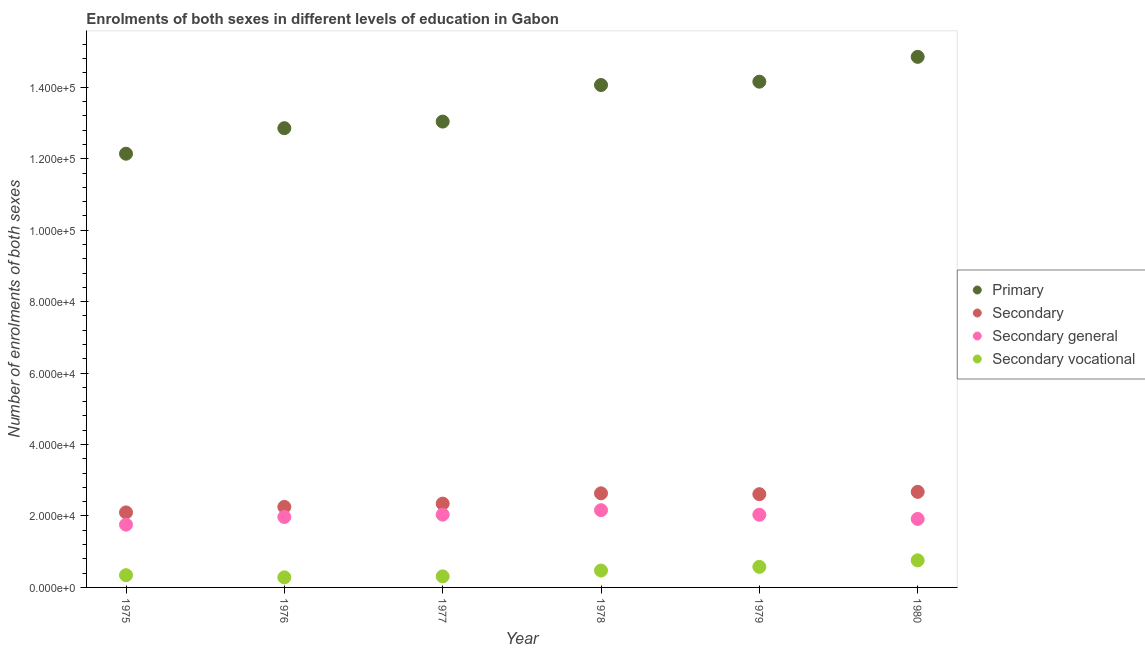What is the number of enrolments in secondary general education in 1977?
Offer a terse response. 2.04e+04. Across all years, what is the maximum number of enrolments in secondary vocational education?
Your response must be concise. 7577. Across all years, what is the minimum number of enrolments in secondary general education?
Your answer should be very brief. 1.76e+04. In which year was the number of enrolments in secondary general education maximum?
Your answer should be very brief. 1978. In which year was the number of enrolments in secondary education minimum?
Offer a very short reply. 1975. What is the total number of enrolments in primary education in the graph?
Make the answer very short. 8.11e+05. What is the difference between the number of enrolments in primary education in 1975 and that in 1978?
Offer a very short reply. -1.92e+04. What is the difference between the number of enrolments in secondary education in 1975 and the number of enrolments in secondary general education in 1979?
Offer a terse response. 655. What is the average number of enrolments in secondary general education per year?
Give a very brief answer. 1.98e+04. In the year 1980, what is the difference between the number of enrolments in secondary vocational education and number of enrolments in secondary general education?
Make the answer very short. -1.16e+04. In how many years, is the number of enrolments in secondary general education greater than 76000?
Offer a very short reply. 0. What is the ratio of the number of enrolments in primary education in 1975 to that in 1978?
Make the answer very short. 0.86. Is the difference between the number of enrolments in secondary education in 1976 and 1978 greater than the difference between the number of enrolments in secondary general education in 1976 and 1978?
Provide a short and direct response. No. What is the difference between the highest and the second highest number of enrolments in secondary general education?
Provide a short and direct response. 1247. What is the difference between the highest and the lowest number of enrolments in secondary vocational education?
Ensure brevity in your answer.  4756. In how many years, is the number of enrolments in secondary vocational education greater than the average number of enrolments in secondary vocational education taken over all years?
Keep it short and to the point. 3. How many dotlines are there?
Your answer should be very brief. 4. How many years are there in the graph?
Your answer should be compact. 6. Are the values on the major ticks of Y-axis written in scientific E-notation?
Keep it short and to the point. Yes. What is the title of the graph?
Your response must be concise. Enrolments of both sexes in different levels of education in Gabon. What is the label or title of the Y-axis?
Give a very brief answer. Number of enrolments of both sexes. What is the Number of enrolments of both sexes in Primary in 1975?
Offer a terse response. 1.21e+05. What is the Number of enrolments of both sexes of Secondary in 1975?
Provide a succinct answer. 2.10e+04. What is the Number of enrolments of both sexes of Secondary general in 1975?
Ensure brevity in your answer.  1.76e+04. What is the Number of enrolments of both sexes in Secondary vocational in 1975?
Keep it short and to the point. 3424. What is the Number of enrolments of both sexes in Primary in 1976?
Offer a terse response. 1.29e+05. What is the Number of enrolments of both sexes in Secondary in 1976?
Keep it short and to the point. 2.25e+04. What is the Number of enrolments of both sexes of Secondary general in 1976?
Keep it short and to the point. 1.97e+04. What is the Number of enrolments of both sexes in Secondary vocational in 1976?
Give a very brief answer. 2821. What is the Number of enrolments of both sexes in Primary in 1977?
Provide a short and direct response. 1.30e+05. What is the Number of enrolments of both sexes of Secondary in 1977?
Provide a succinct answer. 2.35e+04. What is the Number of enrolments of both sexes of Secondary general in 1977?
Your answer should be very brief. 2.04e+04. What is the Number of enrolments of both sexes of Secondary vocational in 1977?
Keep it short and to the point. 3093. What is the Number of enrolments of both sexes of Primary in 1978?
Make the answer very short. 1.41e+05. What is the Number of enrolments of both sexes of Secondary in 1978?
Give a very brief answer. 2.63e+04. What is the Number of enrolments of both sexes in Secondary general in 1978?
Offer a terse response. 2.16e+04. What is the Number of enrolments of both sexes in Secondary vocational in 1978?
Offer a very short reply. 4728. What is the Number of enrolments of both sexes in Primary in 1979?
Give a very brief answer. 1.42e+05. What is the Number of enrolments of both sexes in Secondary in 1979?
Your answer should be compact. 2.61e+04. What is the Number of enrolments of both sexes of Secondary general in 1979?
Your response must be concise. 2.03e+04. What is the Number of enrolments of both sexes of Secondary vocational in 1979?
Provide a succinct answer. 5759. What is the Number of enrolments of both sexes in Primary in 1980?
Provide a succinct answer. 1.49e+05. What is the Number of enrolments of both sexes in Secondary in 1980?
Keep it short and to the point. 2.68e+04. What is the Number of enrolments of both sexes in Secondary general in 1980?
Your response must be concise. 1.92e+04. What is the Number of enrolments of both sexes in Secondary vocational in 1980?
Offer a very short reply. 7577. Across all years, what is the maximum Number of enrolments of both sexes in Primary?
Provide a short and direct response. 1.49e+05. Across all years, what is the maximum Number of enrolments of both sexes in Secondary?
Offer a terse response. 2.68e+04. Across all years, what is the maximum Number of enrolments of both sexes of Secondary general?
Keep it short and to the point. 2.16e+04. Across all years, what is the maximum Number of enrolments of both sexes of Secondary vocational?
Keep it short and to the point. 7577. Across all years, what is the minimum Number of enrolments of both sexes in Primary?
Your answer should be compact. 1.21e+05. Across all years, what is the minimum Number of enrolments of both sexes of Secondary?
Provide a short and direct response. 2.10e+04. Across all years, what is the minimum Number of enrolments of both sexes in Secondary general?
Ensure brevity in your answer.  1.76e+04. Across all years, what is the minimum Number of enrolments of both sexes in Secondary vocational?
Provide a succinct answer. 2821. What is the total Number of enrolments of both sexes in Primary in the graph?
Make the answer very short. 8.11e+05. What is the total Number of enrolments of both sexes in Secondary in the graph?
Provide a succinct answer. 1.46e+05. What is the total Number of enrolments of both sexes in Secondary general in the graph?
Make the answer very short. 1.19e+05. What is the total Number of enrolments of both sexes in Secondary vocational in the graph?
Make the answer very short. 2.74e+04. What is the difference between the Number of enrolments of both sexes of Primary in 1975 and that in 1976?
Give a very brief answer. -7145. What is the difference between the Number of enrolments of both sexes in Secondary in 1975 and that in 1976?
Make the answer very short. -1543. What is the difference between the Number of enrolments of both sexes in Secondary general in 1975 and that in 1976?
Give a very brief answer. -2146. What is the difference between the Number of enrolments of both sexes in Secondary vocational in 1975 and that in 1976?
Give a very brief answer. 603. What is the difference between the Number of enrolments of both sexes of Primary in 1975 and that in 1977?
Your response must be concise. -8991. What is the difference between the Number of enrolments of both sexes in Secondary in 1975 and that in 1977?
Ensure brevity in your answer.  -2461. What is the difference between the Number of enrolments of both sexes in Secondary general in 1975 and that in 1977?
Offer a very short reply. -2792. What is the difference between the Number of enrolments of both sexes in Secondary vocational in 1975 and that in 1977?
Give a very brief answer. 331. What is the difference between the Number of enrolments of both sexes of Primary in 1975 and that in 1978?
Provide a succinct answer. -1.92e+04. What is the difference between the Number of enrolments of both sexes of Secondary in 1975 and that in 1978?
Your answer should be very brief. -5343. What is the difference between the Number of enrolments of both sexes in Secondary general in 1975 and that in 1978?
Provide a short and direct response. -4039. What is the difference between the Number of enrolments of both sexes of Secondary vocational in 1975 and that in 1978?
Give a very brief answer. -1304. What is the difference between the Number of enrolments of both sexes of Primary in 1975 and that in 1979?
Your answer should be compact. -2.02e+04. What is the difference between the Number of enrolments of both sexes of Secondary in 1975 and that in 1979?
Your response must be concise. -5104. What is the difference between the Number of enrolments of both sexes in Secondary general in 1975 and that in 1979?
Ensure brevity in your answer.  -2769. What is the difference between the Number of enrolments of both sexes of Secondary vocational in 1975 and that in 1979?
Keep it short and to the point. -2335. What is the difference between the Number of enrolments of both sexes of Primary in 1975 and that in 1980?
Your answer should be very brief. -2.71e+04. What is the difference between the Number of enrolments of both sexes of Secondary in 1975 and that in 1980?
Ensure brevity in your answer.  -5751. What is the difference between the Number of enrolments of both sexes of Secondary general in 1975 and that in 1980?
Keep it short and to the point. -1598. What is the difference between the Number of enrolments of both sexes of Secondary vocational in 1975 and that in 1980?
Offer a terse response. -4153. What is the difference between the Number of enrolments of both sexes of Primary in 1976 and that in 1977?
Keep it short and to the point. -1846. What is the difference between the Number of enrolments of both sexes of Secondary in 1976 and that in 1977?
Give a very brief answer. -918. What is the difference between the Number of enrolments of both sexes in Secondary general in 1976 and that in 1977?
Provide a succinct answer. -646. What is the difference between the Number of enrolments of both sexes of Secondary vocational in 1976 and that in 1977?
Keep it short and to the point. -272. What is the difference between the Number of enrolments of both sexes of Primary in 1976 and that in 1978?
Provide a succinct answer. -1.21e+04. What is the difference between the Number of enrolments of both sexes of Secondary in 1976 and that in 1978?
Your response must be concise. -3800. What is the difference between the Number of enrolments of both sexes in Secondary general in 1976 and that in 1978?
Offer a very short reply. -1893. What is the difference between the Number of enrolments of both sexes of Secondary vocational in 1976 and that in 1978?
Your answer should be very brief. -1907. What is the difference between the Number of enrolments of both sexes in Primary in 1976 and that in 1979?
Keep it short and to the point. -1.30e+04. What is the difference between the Number of enrolments of both sexes of Secondary in 1976 and that in 1979?
Give a very brief answer. -3561. What is the difference between the Number of enrolments of both sexes of Secondary general in 1976 and that in 1979?
Your response must be concise. -623. What is the difference between the Number of enrolments of both sexes of Secondary vocational in 1976 and that in 1979?
Provide a short and direct response. -2938. What is the difference between the Number of enrolments of both sexes in Primary in 1976 and that in 1980?
Your response must be concise. -2.00e+04. What is the difference between the Number of enrolments of both sexes of Secondary in 1976 and that in 1980?
Offer a very short reply. -4208. What is the difference between the Number of enrolments of both sexes in Secondary general in 1976 and that in 1980?
Your answer should be very brief. 548. What is the difference between the Number of enrolments of both sexes in Secondary vocational in 1976 and that in 1980?
Your answer should be very brief. -4756. What is the difference between the Number of enrolments of both sexes of Primary in 1977 and that in 1978?
Provide a succinct answer. -1.02e+04. What is the difference between the Number of enrolments of both sexes in Secondary in 1977 and that in 1978?
Keep it short and to the point. -2882. What is the difference between the Number of enrolments of both sexes of Secondary general in 1977 and that in 1978?
Provide a succinct answer. -1247. What is the difference between the Number of enrolments of both sexes in Secondary vocational in 1977 and that in 1978?
Keep it short and to the point. -1635. What is the difference between the Number of enrolments of both sexes of Primary in 1977 and that in 1979?
Your response must be concise. -1.12e+04. What is the difference between the Number of enrolments of both sexes of Secondary in 1977 and that in 1979?
Keep it short and to the point. -2643. What is the difference between the Number of enrolments of both sexes in Secondary general in 1977 and that in 1979?
Give a very brief answer. 23. What is the difference between the Number of enrolments of both sexes of Secondary vocational in 1977 and that in 1979?
Offer a terse response. -2666. What is the difference between the Number of enrolments of both sexes in Primary in 1977 and that in 1980?
Ensure brevity in your answer.  -1.81e+04. What is the difference between the Number of enrolments of both sexes in Secondary in 1977 and that in 1980?
Keep it short and to the point. -3290. What is the difference between the Number of enrolments of both sexes of Secondary general in 1977 and that in 1980?
Keep it short and to the point. 1194. What is the difference between the Number of enrolments of both sexes in Secondary vocational in 1977 and that in 1980?
Offer a terse response. -4484. What is the difference between the Number of enrolments of both sexes of Primary in 1978 and that in 1979?
Provide a short and direct response. -937. What is the difference between the Number of enrolments of both sexes of Secondary in 1978 and that in 1979?
Provide a short and direct response. 239. What is the difference between the Number of enrolments of both sexes in Secondary general in 1978 and that in 1979?
Provide a short and direct response. 1270. What is the difference between the Number of enrolments of both sexes of Secondary vocational in 1978 and that in 1979?
Keep it short and to the point. -1031. What is the difference between the Number of enrolments of both sexes in Primary in 1978 and that in 1980?
Provide a short and direct response. -7888. What is the difference between the Number of enrolments of both sexes in Secondary in 1978 and that in 1980?
Offer a very short reply. -408. What is the difference between the Number of enrolments of both sexes in Secondary general in 1978 and that in 1980?
Provide a short and direct response. 2441. What is the difference between the Number of enrolments of both sexes in Secondary vocational in 1978 and that in 1980?
Give a very brief answer. -2849. What is the difference between the Number of enrolments of both sexes of Primary in 1979 and that in 1980?
Make the answer very short. -6951. What is the difference between the Number of enrolments of both sexes in Secondary in 1979 and that in 1980?
Your answer should be very brief. -647. What is the difference between the Number of enrolments of both sexes in Secondary general in 1979 and that in 1980?
Keep it short and to the point. 1171. What is the difference between the Number of enrolments of both sexes of Secondary vocational in 1979 and that in 1980?
Offer a very short reply. -1818. What is the difference between the Number of enrolments of both sexes in Primary in 1975 and the Number of enrolments of both sexes in Secondary in 1976?
Offer a very short reply. 9.89e+04. What is the difference between the Number of enrolments of both sexes in Primary in 1975 and the Number of enrolments of both sexes in Secondary general in 1976?
Offer a very short reply. 1.02e+05. What is the difference between the Number of enrolments of both sexes in Primary in 1975 and the Number of enrolments of both sexes in Secondary vocational in 1976?
Provide a short and direct response. 1.19e+05. What is the difference between the Number of enrolments of both sexes in Secondary in 1975 and the Number of enrolments of both sexes in Secondary general in 1976?
Your answer should be very brief. 1278. What is the difference between the Number of enrolments of both sexes in Secondary in 1975 and the Number of enrolments of both sexes in Secondary vocational in 1976?
Keep it short and to the point. 1.82e+04. What is the difference between the Number of enrolments of both sexes in Secondary general in 1975 and the Number of enrolments of both sexes in Secondary vocational in 1976?
Give a very brief answer. 1.48e+04. What is the difference between the Number of enrolments of both sexes in Primary in 1975 and the Number of enrolments of both sexes in Secondary in 1977?
Provide a short and direct response. 9.79e+04. What is the difference between the Number of enrolments of both sexes in Primary in 1975 and the Number of enrolments of both sexes in Secondary general in 1977?
Offer a very short reply. 1.01e+05. What is the difference between the Number of enrolments of both sexes of Primary in 1975 and the Number of enrolments of both sexes of Secondary vocational in 1977?
Your answer should be compact. 1.18e+05. What is the difference between the Number of enrolments of both sexes in Secondary in 1975 and the Number of enrolments of both sexes in Secondary general in 1977?
Make the answer very short. 632. What is the difference between the Number of enrolments of both sexes of Secondary in 1975 and the Number of enrolments of both sexes of Secondary vocational in 1977?
Your response must be concise. 1.79e+04. What is the difference between the Number of enrolments of both sexes in Secondary general in 1975 and the Number of enrolments of both sexes in Secondary vocational in 1977?
Your answer should be very brief. 1.45e+04. What is the difference between the Number of enrolments of both sexes of Primary in 1975 and the Number of enrolments of both sexes of Secondary in 1978?
Offer a terse response. 9.51e+04. What is the difference between the Number of enrolments of both sexes in Primary in 1975 and the Number of enrolments of both sexes in Secondary general in 1978?
Keep it short and to the point. 9.98e+04. What is the difference between the Number of enrolments of both sexes of Primary in 1975 and the Number of enrolments of both sexes of Secondary vocational in 1978?
Your answer should be compact. 1.17e+05. What is the difference between the Number of enrolments of both sexes in Secondary in 1975 and the Number of enrolments of both sexes in Secondary general in 1978?
Provide a succinct answer. -615. What is the difference between the Number of enrolments of both sexes in Secondary in 1975 and the Number of enrolments of both sexes in Secondary vocational in 1978?
Keep it short and to the point. 1.63e+04. What is the difference between the Number of enrolments of both sexes of Secondary general in 1975 and the Number of enrolments of both sexes of Secondary vocational in 1978?
Provide a succinct answer. 1.28e+04. What is the difference between the Number of enrolments of both sexes in Primary in 1975 and the Number of enrolments of both sexes in Secondary in 1979?
Your answer should be very brief. 9.53e+04. What is the difference between the Number of enrolments of both sexes of Primary in 1975 and the Number of enrolments of both sexes of Secondary general in 1979?
Your answer should be compact. 1.01e+05. What is the difference between the Number of enrolments of both sexes in Primary in 1975 and the Number of enrolments of both sexes in Secondary vocational in 1979?
Keep it short and to the point. 1.16e+05. What is the difference between the Number of enrolments of both sexes of Secondary in 1975 and the Number of enrolments of both sexes of Secondary general in 1979?
Your response must be concise. 655. What is the difference between the Number of enrolments of both sexes of Secondary in 1975 and the Number of enrolments of both sexes of Secondary vocational in 1979?
Provide a succinct answer. 1.52e+04. What is the difference between the Number of enrolments of both sexes of Secondary general in 1975 and the Number of enrolments of both sexes of Secondary vocational in 1979?
Your answer should be compact. 1.18e+04. What is the difference between the Number of enrolments of both sexes of Primary in 1975 and the Number of enrolments of both sexes of Secondary in 1980?
Provide a short and direct response. 9.47e+04. What is the difference between the Number of enrolments of both sexes of Primary in 1975 and the Number of enrolments of both sexes of Secondary general in 1980?
Keep it short and to the point. 1.02e+05. What is the difference between the Number of enrolments of both sexes of Primary in 1975 and the Number of enrolments of both sexes of Secondary vocational in 1980?
Provide a short and direct response. 1.14e+05. What is the difference between the Number of enrolments of both sexes of Secondary in 1975 and the Number of enrolments of both sexes of Secondary general in 1980?
Provide a short and direct response. 1826. What is the difference between the Number of enrolments of both sexes of Secondary in 1975 and the Number of enrolments of both sexes of Secondary vocational in 1980?
Provide a short and direct response. 1.34e+04. What is the difference between the Number of enrolments of both sexes in Secondary general in 1975 and the Number of enrolments of both sexes in Secondary vocational in 1980?
Make the answer very short. 9998. What is the difference between the Number of enrolments of both sexes in Primary in 1976 and the Number of enrolments of both sexes in Secondary in 1977?
Make the answer very short. 1.05e+05. What is the difference between the Number of enrolments of both sexes of Primary in 1976 and the Number of enrolments of both sexes of Secondary general in 1977?
Ensure brevity in your answer.  1.08e+05. What is the difference between the Number of enrolments of both sexes in Primary in 1976 and the Number of enrolments of both sexes in Secondary vocational in 1977?
Provide a succinct answer. 1.25e+05. What is the difference between the Number of enrolments of both sexes of Secondary in 1976 and the Number of enrolments of both sexes of Secondary general in 1977?
Give a very brief answer. 2175. What is the difference between the Number of enrolments of both sexes in Secondary in 1976 and the Number of enrolments of both sexes in Secondary vocational in 1977?
Provide a succinct answer. 1.94e+04. What is the difference between the Number of enrolments of both sexes in Secondary general in 1976 and the Number of enrolments of both sexes in Secondary vocational in 1977?
Give a very brief answer. 1.66e+04. What is the difference between the Number of enrolments of both sexes in Primary in 1976 and the Number of enrolments of both sexes in Secondary in 1978?
Your answer should be compact. 1.02e+05. What is the difference between the Number of enrolments of both sexes in Primary in 1976 and the Number of enrolments of both sexes in Secondary general in 1978?
Provide a succinct answer. 1.07e+05. What is the difference between the Number of enrolments of both sexes in Primary in 1976 and the Number of enrolments of both sexes in Secondary vocational in 1978?
Offer a terse response. 1.24e+05. What is the difference between the Number of enrolments of both sexes in Secondary in 1976 and the Number of enrolments of both sexes in Secondary general in 1978?
Provide a short and direct response. 928. What is the difference between the Number of enrolments of both sexes of Secondary in 1976 and the Number of enrolments of both sexes of Secondary vocational in 1978?
Provide a succinct answer. 1.78e+04. What is the difference between the Number of enrolments of both sexes in Secondary general in 1976 and the Number of enrolments of both sexes in Secondary vocational in 1978?
Your response must be concise. 1.50e+04. What is the difference between the Number of enrolments of both sexes of Primary in 1976 and the Number of enrolments of both sexes of Secondary in 1979?
Your answer should be compact. 1.02e+05. What is the difference between the Number of enrolments of both sexes in Primary in 1976 and the Number of enrolments of both sexes in Secondary general in 1979?
Give a very brief answer. 1.08e+05. What is the difference between the Number of enrolments of both sexes in Primary in 1976 and the Number of enrolments of both sexes in Secondary vocational in 1979?
Ensure brevity in your answer.  1.23e+05. What is the difference between the Number of enrolments of both sexes in Secondary in 1976 and the Number of enrolments of both sexes in Secondary general in 1979?
Give a very brief answer. 2198. What is the difference between the Number of enrolments of both sexes in Secondary in 1976 and the Number of enrolments of both sexes in Secondary vocational in 1979?
Give a very brief answer. 1.68e+04. What is the difference between the Number of enrolments of both sexes of Secondary general in 1976 and the Number of enrolments of both sexes of Secondary vocational in 1979?
Your answer should be very brief. 1.40e+04. What is the difference between the Number of enrolments of both sexes of Primary in 1976 and the Number of enrolments of both sexes of Secondary in 1980?
Offer a terse response. 1.02e+05. What is the difference between the Number of enrolments of both sexes of Primary in 1976 and the Number of enrolments of both sexes of Secondary general in 1980?
Keep it short and to the point. 1.09e+05. What is the difference between the Number of enrolments of both sexes in Primary in 1976 and the Number of enrolments of both sexes in Secondary vocational in 1980?
Provide a succinct answer. 1.21e+05. What is the difference between the Number of enrolments of both sexes in Secondary in 1976 and the Number of enrolments of both sexes in Secondary general in 1980?
Keep it short and to the point. 3369. What is the difference between the Number of enrolments of both sexes of Secondary in 1976 and the Number of enrolments of both sexes of Secondary vocational in 1980?
Make the answer very short. 1.50e+04. What is the difference between the Number of enrolments of both sexes in Secondary general in 1976 and the Number of enrolments of both sexes in Secondary vocational in 1980?
Give a very brief answer. 1.21e+04. What is the difference between the Number of enrolments of both sexes of Primary in 1977 and the Number of enrolments of both sexes of Secondary in 1978?
Give a very brief answer. 1.04e+05. What is the difference between the Number of enrolments of both sexes of Primary in 1977 and the Number of enrolments of both sexes of Secondary general in 1978?
Keep it short and to the point. 1.09e+05. What is the difference between the Number of enrolments of both sexes of Primary in 1977 and the Number of enrolments of both sexes of Secondary vocational in 1978?
Give a very brief answer. 1.26e+05. What is the difference between the Number of enrolments of both sexes in Secondary in 1977 and the Number of enrolments of both sexes in Secondary general in 1978?
Offer a terse response. 1846. What is the difference between the Number of enrolments of both sexes of Secondary in 1977 and the Number of enrolments of both sexes of Secondary vocational in 1978?
Give a very brief answer. 1.87e+04. What is the difference between the Number of enrolments of both sexes in Secondary general in 1977 and the Number of enrolments of both sexes in Secondary vocational in 1978?
Provide a succinct answer. 1.56e+04. What is the difference between the Number of enrolments of both sexes in Primary in 1977 and the Number of enrolments of both sexes in Secondary in 1979?
Your response must be concise. 1.04e+05. What is the difference between the Number of enrolments of both sexes in Primary in 1977 and the Number of enrolments of both sexes in Secondary general in 1979?
Provide a succinct answer. 1.10e+05. What is the difference between the Number of enrolments of both sexes in Primary in 1977 and the Number of enrolments of both sexes in Secondary vocational in 1979?
Provide a short and direct response. 1.25e+05. What is the difference between the Number of enrolments of both sexes in Secondary in 1977 and the Number of enrolments of both sexes in Secondary general in 1979?
Provide a short and direct response. 3116. What is the difference between the Number of enrolments of both sexes in Secondary in 1977 and the Number of enrolments of both sexes in Secondary vocational in 1979?
Give a very brief answer. 1.77e+04. What is the difference between the Number of enrolments of both sexes in Secondary general in 1977 and the Number of enrolments of both sexes in Secondary vocational in 1979?
Give a very brief answer. 1.46e+04. What is the difference between the Number of enrolments of both sexes in Primary in 1977 and the Number of enrolments of both sexes in Secondary in 1980?
Your answer should be compact. 1.04e+05. What is the difference between the Number of enrolments of both sexes in Primary in 1977 and the Number of enrolments of both sexes in Secondary general in 1980?
Offer a terse response. 1.11e+05. What is the difference between the Number of enrolments of both sexes in Primary in 1977 and the Number of enrolments of both sexes in Secondary vocational in 1980?
Make the answer very short. 1.23e+05. What is the difference between the Number of enrolments of both sexes in Secondary in 1977 and the Number of enrolments of both sexes in Secondary general in 1980?
Offer a terse response. 4287. What is the difference between the Number of enrolments of both sexes of Secondary in 1977 and the Number of enrolments of both sexes of Secondary vocational in 1980?
Your response must be concise. 1.59e+04. What is the difference between the Number of enrolments of both sexes in Secondary general in 1977 and the Number of enrolments of both sexes in Secondary vocational in 1980?
Ensure brevity in your answer.  1.28e+04. What is the difference between the Number of enrolments of both sexes of Primary in 1978 and the Number of enrolments of both sexes of Secondary in 1979?
Provide a short and direct response. 1.15e+05. What is the difference between the Number of enrolments of both sexes in Primary in 1978 and the Number of enrolments of both sexes in Secondary general in 1979?
Make the answer very short. 1.20e+05. What is the difference between the Number of enrolments of both sexes in Primary in 1978 and the Number of enrolments of both sexes in Secondary vocational in 1979?
Offer a terse response. 1.35e+05. What is the difference between the Number of enrolments of both sexes of Secondary in 1978 and the Number of enrolments of both sexes of Secondary general in 1979?
Offer a terse response. 5998. What is the difference between the Number of enrolments of both sexes of Secondary in 1978 and the Number of enrolments of both sexes of Secondary vocational in 1979?
Keep it short and to the point. 2.06e+04. What is the difference between the Number of enrolments of both sexes in Secondary general in 1978 and the Number of enrolments of both sexes in Secondary vocational in 1979?
Your response must be concise. 1.59e+04. What is the difference between the Number of enrolments of both sexes of Primary in 1978 and the Number of enrolments of both sexes of Secondary in 1980?
Your answer should be very brief. 1.14e+05. What is the difference between the Number of enrolments of both sexes in Primary in 1978 and the Number of enrolments of both sexes in Secondary general in 1980?
Provide a succinct answer. 1.21e+05. What is the difference between the Number of enrolments of both sexes in Primary in 1978 and the Number of enrolments of both sexes in Secondary vocational in 1980?
Your answer should be very brief. 1.33e+05. What is the difference between the Number of enrolments of both sexes of Secondary in 1978 and the Number of enrolments of both sexes of Secondary general in 1980?
Your answer should be very brief. 7169. What is the difference between the Number of enrolments of both sexes of Secondary in 1978 and the Number of enrolments of both sexes of Secondary vocational in 1980?
Ensure brevity in your answer.  1.88e+04. What is the difference between the Number of enrolments of both sexes in Secondary general in 1978 and the Number of enrolments of both sexes in Secondary vocational in 1980?
Give a very brief answer. 1.40e+04. What is the difference between the Number of enrolments of both sexes in Primary in 1979 and the Number of enrolments of both sexes in Secondary in 1980?
Keep it short and to the point. 1.15e+05. What is the difference between the Number of enrolments of both sexes of Primary in 1979 and the Number of enrolments of both sexes of Secondary general in 1980?
Make the answer very short. 1.22e+05. What is the difference between the Number of enrolments of both sexes in Primary in 1979 and the Number of enrolments of both sexes in Secondary vocational in 1980?
Your answer should be compact. 1.34e+05. What is the difference between the Number of enrolments of both sexes in Secondary in 1979 and the Number of enrolments of both sexes in Secondary general in 1980?
Offer a very short reply. 6930. What is the difference between the Number of enrolments of both sexes in Secondary in 1979 and the Number of enrolments of both sexes in Secondary vocational in 1980?
Ensure brevity in your answer.  1.85e+04. What is the difference between the Number of enrolments of both sexes in Secondary general in 1979 and the Number of enrolments of both sexes in Secondary vocational in 1980?
Provide a short and direct response. 1.28e+04. What is the average Number of enrolments of both sexes in Primary per year?
Provide a succinct answer. 1.35e+05. What is the average Number of enrolments of both sexes of Secondary per year?
Your response must be concise. 2.44e+04. What is the average Number of enrolments of both sexes of Secondary general per year?
Provide a short and direct response. 1.98e+04. What is the average Number of enrolments of both sexes in Secondary vocational per year?
Ensure brevity in your answer.  4567. In the year 1975, what is the difference between the Number of enrolments of both sexes of Primary and Number of enrolments of both sexes of Secondary?
Ensure brevity in your answer.  1.00e+05. In the year 1975, what is the difference between the Number of enrolments of both sexes in Primary and Number of enrolments of both sexes in Secondary general?
Offer a terse response. 1.04e+05. In the year 1975, what is the difference between the Number of enrolments of both sexes in Primary and Number of enrolments of both sexes in Secondary vocational?
Ensure brevity in your answer.  1.18e+05. In the year 1975, what is the difference between the Number of enrolments of both sexes in Secondary and Number of enrolments of both sexes in Secondary general?
Keep it short and to the point. 3424. In the year 1975, what is the difference between the Number of enrolments of both sexes of Secondary and Number of enrolments of both sexes of Secondary vocational?
Offer a very short reply. 1.76e+04. In the year 1975, what is the difference between the Number of enrolments of both sexes of Secondary general and Number of enrolments of both sexes of Secondary vocational?
Provide a short and direct response. 1.42e+04. In the year 1976, what is the difference between the Number of enrolments of both sexes of Primary and Number of enrolments of both sexes of Secondary?
Your response must be concise. 1.06e+05. In the year 1976, what is the difference between the Number of enrolments of both sexes in Primary and Number of enrolments of both sexes in Secondary general?
Give a very brief answer. 1.09e+05. In the year 1976, what is the difference between the Number of enrolments of both sexes of Primary and Number of enrolments of both sexes of Secondary vocational?
Provide a short and direct response. 1.26e+05. In the year 1976, what is the difference between the Number of enrolments of both sexes of Secondary and Number of enrolments of both sexes of Secondary general?
Your answer should be very brief. 2821. In the year 1976, what is the difference between the Number of enrolments of both sexes of Secondary and Number of enrolments of both sexes of Secondary vocational?
Your answer should be compact. 1.97e+04. In the year 1976, what is the difference between the Number of enrolments of both sexes in Secondary general and Number of enrolments of both sexes in Secondary vocational?
Your response must be concise. 1.69e+04. In the year 1977, what is the difference between the Number of enrolments of both sexes in Primary and Number of enrolments of both sexes in Secondary?
Your response must be concise. 1.07e+05. In the year 1977, what is the difference between the Number of enrolments of both sexes in Primary and Number of enrolments of both sexes in Secondary general?
Ensure brevity in your answer.  1.10e+05. In the year 1977, what is the difference between the Number of enrolments of both sexes in Primary and Number of enrolments of both sexes in Secondary vocational?
Provide a succinct answer. 1.27e+05. In the year 1977, what is the difference between the Number of enrolments of both sexes of Secondary and Number of enrolments of both sexes of Secondary general?
Keep it short and to the point. 3093. In the year 1977, what is the difference between the Number of enrolments of both sexes in Secondary and Number of enrolments of both sexes in Secondary vocational?
Provide a short and direct response. 2.04e+04. In the year 1977, what is the difference between the Number of enrolments of both sexes of Secondary general and Number of enrolments of both sexes of Secondary vocational?
Give a very brief answer. 1.73e+04. In the year 1978, what is the difference between the Number of enrolments of both sexes of Primary and Number of enrolments of both sexes of Secondary?
Provide a succinct answer. 1.14e+05. In the year 1978, what is the difference between the Number of enrolments of both sexes in Primary and Number of enrolments of both sexes in Secondary general?
Provide a short and direct response. 1.19e+05. In the year 1978, what is the difference between the Number of enrolments of both sexes of Primary and Number of enrolments of both sexes of Secondary vocational?
Ensure brevity in your answer.  1.36e+05. In the year 1978, what is the difference between the Number of enrolments of both sexes in Secondary and Number of enrolments of both sexes in Secondary general?
Your response must be concise. 4728. In the year 1978, what is the difference between the Number of enrolments of both sexes of Secondary and Number of enrolments of both sexes of Secondary vocational?
Offer a terse response. 2.16e+04. In the year 1978, what is the difference between the Number of enrolments of both sexes of Secondary general and Number of enrolments of both sexes of Secondary vocational?
Your response must be concise. 1.69e+04. In the year 1979, what is the difference between the Number of enrolments of both sexes in Primary and Number of enrolments of both sexes in Secondary?
Give a very brief answer. 1.15e+05. In the year 1979, what is the difference between the Number of enrolments of both sexes of Primary and Number of enrolments of both sexes of Secondary general?
Offer a terse response. 1.21e+05. In the year 1979, what is the difference between the Number of enrolments of both sexes of Primary and Number of enrolments of both sexes of Secondary vocational?
Ensure brevity in your answer.  1.36e+05. In the year 1979, what is the difference between the Number of enrolments of both sexes of Secondary and Number of enrolments of both sexes of Secondary general?
Provide a succinct answer. 5759. In the year 1979, what is the difference between the Number of enrolments of both sexes of Secondary and Number of enrolments of both sexes of Secondary vocational?
Provide a succinct answer. 2.03e+04. In the year 1979, what is the difference between the Number of enrolments of both sexes of Secondary general and Number of enrolments of both sexes of Secondary vocational?
Your answer should be very brief. 1.46e+04. In the year 1980, what is the difference between the Number of enrolments of both sexes in Primary and Number of enrolments of both sexes in Secondary?
Offer a terse response. 1.22e+05. In the year 1980, what is the difference between the Number of enrolments of both sexes in Primary and Number of enrolments of both sexes in Secondary general?
Ensure brevity in your answer.  1.29e+05. In the year 1980, what is the difference between the Number of enrolments of both sexes in Primary and Number of enrolments of both sexes in Secondary vocational?
Give a very brief answer. 1.41e+05. In the year 1980, what is the difference between the Number of enrolments of both sexes in Secondary and Number of enrolments of both sexes in Secondary general?
Offer a very short reply. 7577. In the year 1980, what is the difference between the Number of enrolments of both sexes in Secondary and Number of enrolments of both sexes in Secondary vocational?
Ensure brevity in your answer.  1.92e+04. In the year 1980, what is the difference between the Number of enrolments of both sexes in Secondary general and Number of enrolments of both sexes in Secondary vocational?
Ensure brevity in your answer.  1.16e+04. What is the ratio of the Number of enrolments of both sexes in Primary in 1975 to that in 1976?
Keep it short and to the point. 0.94. What is the ratio of the Number of enrolments of both sexes of Secondary in 1975 to that in 1976?
Offer a terse response. 0.93. What is the ratio of the Number of enrolments of both sexes of Secondary general in 1975 to that in 1976?
Provide a succinct answer. 0.89. What is the ratio of the Number of enrolments of both sexes of Secondary vocational in 1975 to that in 1976?
Ensure brevity in your answer.  1.21. What is the ratio of the Number of enrolments of both sexes of Secondary in 1975 to that in 1977?
Your answer should be very brief. 0.9. What is the ratio of the Number of enrolments of both sexes of Secondary general in 1975 to that in 1977?
Make the answer very short. 0.86. What is the ratio of the Number of enrolments of both sexes in Secondary vocational in 1975 to that in 1977?
Give a very brief answer. 1.11. What is the ratio of the Number of enrolments of both sexes of Primary in 1975 to that in 1978?
Your answer should be very brief. 0.86. What is the ratio of the Number of enrolments of both sexes in Secondary in 1975 to that in 1978?
Make the answer very short. 0.8. What is the ratio of the Number of enrolments of both sexes of Secondary general in 1975 to that in 1978?
Ensure brevity in your answer.  0.81. What is the ratio of the Number of enrolments of both sexes of Secondary vocational in 1975 to that in 1978?
Keep it short and to the point. 0.72. What is the ratio of the Number of enrolments of both sexes of Primary in 1975 to that in 1979?
Keep it short and to the point. 0.86. What is the ratio of the Number of enrolments of both sexes in Secondary in 1975 to that in 1979?
Your response must be concise. 0.8. What is the ratio of the Number of enrolments of both sexes in Secondary general in 1975 to that in 1979?
Offer a terse response. 0.86. What is the ratio of the Number of enrolments of both sexes of Secondary vocational in 1975 to that in 1979?
Provide a succinct answer. 0.59. What is the ratio of the Number of enrolments of both sexes in Primary in 1975 to that in 1980?
Offer a very short reply. 0.82. What is the ratio of the Number of enrolments of both sexes of Secondary in 1975 to that in 1980?
Provide a succinct answer. 0.79. What is the ratio of the Number of enrolments of both sexes of Secondary vocational in 1975 to that in 1980?
Ensure brevity in your answer.  0.45. What is the ratio of the Number of enrolments of both sexes of Primary in 1976 to that in 1977?
Provide a succinct answer. 0.99. What is the ratio of the Number of enrolments of both sexes in Secondary in 1976 to that in 1977?
Make the answer very short. 0.96. What is the ratio of the Number of enrolments of both sexes of Secondary general in 1976 to that in 1977?
Your response must be concise. 0.97. What is the ratio of the Number of enrolments of both sexes in Secondary vocational in 1976 to that in 1977?
Keep it short and to the point. 0.91. What is the ratio of the Number of enrolments of both sexes of Primary in 1976 to that in 1978?
Your answer should be compact. 0.91. What is the ratio of the Number of enrolments of both sexes in Secondary in 1976 to that in 1978?
Offer a very short reply. 0.86. What is the ratio of the Number of enrolments of both sexes of Secondary general in 1976 to that in 1978?
Provide a succinct answer. 0.91. What is the ratio of the Number of enrolments of both sexes in Secondary vocational in 1976 to that in 1978?
Your answer should be compact. 0.6. What is the ratio of the Number of enrolments of both sexes of Primary in 1976 to that in 1979?
Make the answer very short. 0.91. What is the ratio of the Number of enrolments of both sexes of Secondary in 1976 to that in 1979?
Offer a terse response. 0.86. What is the ratio of the Number of enrolments of both sexes in Secondary general in 1976 to that in 1979?
Keep it short and to the point. 0.97. What is the ratio of the Number of enrolments of both sexes of Secondary vocational in 1976 to that in 1979?
Offer a terse response. 0.49. What is the ratio of the Number of enrolments of both sexes in Primary in 1976 to that in 1980?
Your answer should be very brief. 0.87. What is the ratio of the Number of enrolments of both sexes in Secondary in 1976 to that in 1980?
Provide a short and direct response. 0.84. What is the ratio of the Number of enrolments of both sexes in Secondary general in 1976 to that in 1980?
Your answer should be very brief. 1.03. What is the ratio of the Number of enrolments of both sexes of Secondary vocational in 1976 to that in 1980?
Your answer should be very brief. 0.37. What is the ratio of the Number of enrolments of both sexes in Primary in 1977 to that in 1978?
Offer a terse response. 0.93. What is the ratio of the Number of enrolments of both sexes of Secondary in 1977 to that in 1978?
Provide a succinct answer. 0.89. What is the ratio of the Number of enrolments of both sexes of Secondary general in 1977 to that in 1978?
Ensure brevity in your answer.  0.94. What is the ratio of the Number of enrolments of both sexes of Secondary vocational in 1977 to that in 1978?
Keep it short and to the point. 0.65. What is the ratio of the Number of enrolments of both sexes of Primary in 1977 to that in 1979?
Offer a very short reply. 0.92. What is the ratio of the Number of enrolments of both sexes in Secondary in 1977 to that in 1979?
Your answer should be compact. 0.9. What is the ratio of the Number of enrolments of both sexes in Secondary general in 1977 to that in 1979?
Give a very brief answer. 1. What is the ratio of the Number of enrolments of both sexes in Secondary vocational in 1977 to that in 1979?
Offer a terse response. 0.54. What is the ratio of the Number of enrolments of both sexes in Primary in 1977 to that in 1980?
Ensure brevity in your answer.  0.88. What is the ratio of the Number of enrolments of both sexes in Secondary in 1977 to that in 1980?
Make the answer very short. 0.88. What is the ratio of the Number of enrolments of both sexes of Secondary general in 1977 to that in 1980?
Offer a very short reply. 1.06. What is the ratio of the Number of enrolments of both sexes of Secondary vocational in 1977 to that in 1980?
Offer a very short reply. 0.41. What is the ratio of the Number of enrolments of both sexes in Primary in 1978 to that in 1979?
Make the answer very short. 0.99. What is the ratio of the Number of enrolments of both sexes of Secondary in 1978 to that in 1979?
Ensure brevity in your answer.  1.01. What is the ratio of the Number of enrolments of both sexes in Secondary general in 1978 to that in 1979?
Keep it short and to the point. 1.06. What is the ratio of the Number of enrolments of both sexes of Secondary vocational in 1978 to that in 1979?
Provide a succinct answer. 0.82. What is the ratio of the Number of enrolments of both sexes in Primary in 1978 to that in 1980?
Keep it short and to the point. 0.95. What is the ratio of the Number of enrolments of both sexes in Secondary in 1978 to that in 1980?
Your response must be concise. 0.98. What is the ratio of the Number of enrolments of both sexes in Secondary general in 1978 to that in 1980?
Make the answer very short. 1.13. What is the ratio of the Number of enrolments of both sexes of Secondary vocational in 1978 to that in 1980?
Your answer should be very brief. 0.62. What is the ratio of the Number of enrolments of both sexes of Primary in 1979 to that in 1980?
Your answer should be very brief. 0.95. What is the ratio of the Number of enrolments of both sexes of Secondary in 1979 to that in 1980?
Offer a terse response. 0.98. What is the ratio of the Number of enrolments of both sexes of Secondary general in 1979 to that in 1980?
Your response must be concise. 1.06. What is the ratio of the Number of enrolments of both sexes in Secondary vocational in 1979 to that in 1980?
Give a very brief answer. 0.76. What is the difference between the highest and the second highest Number of enrolments of both sexes of Primary?
Offer a very short reply. 6951. What is the difference between the highest and the second highest Number of enrolments of both sexes of Secondary?
Your answer should be very brief. 408. What is the difference between the highest and the second highest Number of enrolments of both sexes of Secondary general?
Offer a terse response. 1247. What is the difference between the highest and the second highest Number of enrolments of both sexes in Secondary vocational?
Keep it short and to the point. 1818. What is the difference between the highest and the lowest Number of enrolments of both sexes in Primary?
Offer a terse response. 2.71e+04. What is the difference between the highest and the lowest Number of enrolments of both sexes of Secondary?
Provide a short and direct response. 5751. What is the difference between the highest and the lowest Number of enrolments of both sexes of Secondary general?
Your answer should be compact. 4039. What is the difference between the highest and the lowest Number of enrolments of both sexes in Secondary vocational?
Your answer should be very brief. 4756. 